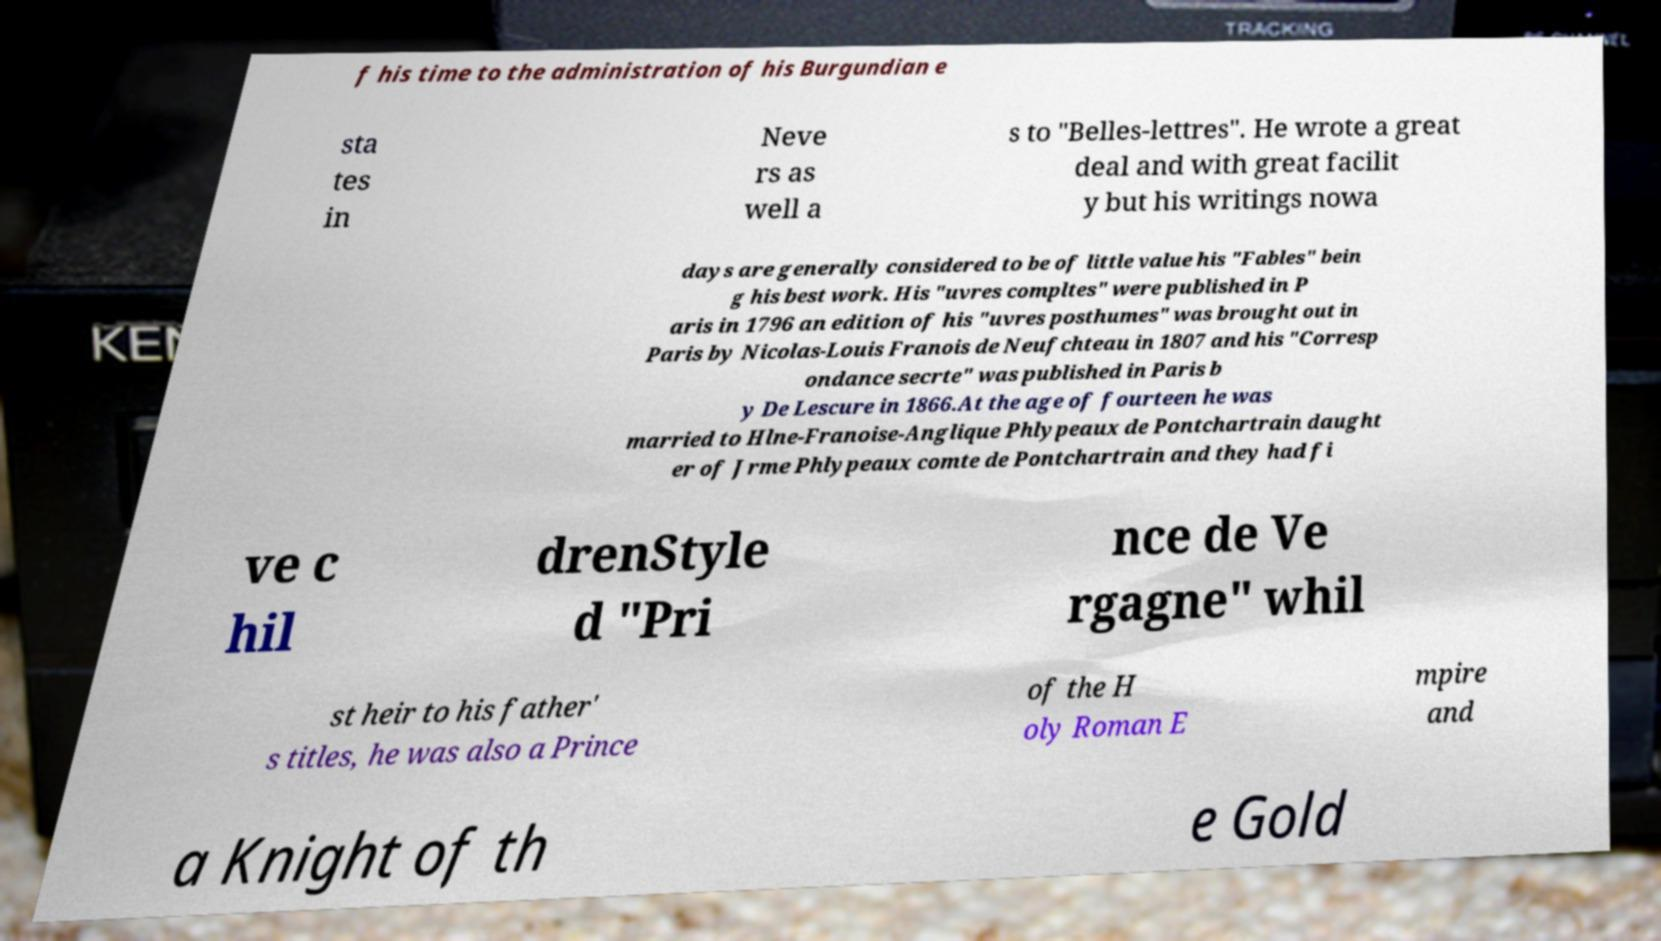Can you accurately transcribe the text from the provided image for me? f his time to the administration of his Burgundian e sta tes in Neve rs as well a s to "Belles-lettres". He wrote a great deal and with great facilit y but his writings nowa days are generally considered to be of little value his "Fables" bein g his best work. His "uvres compltes" were published in P aris in 1796 an edition of his "uvres posthumes" was brought out in Paris by Nicolas-Louis Franois de Neufchteau in 1807 and his "Corresp ondance secrte" was published in Paris b y De Lescure in 1866.At the age of fourteen he was married to Hlne-Franoise-Anglique Phlypeaux de Pontchartrain daught er of Jrme Phlypeaux comte de Pontchartrain and they had fi ve c hil drenStyle d "Pri nce de Ve rgagne" whil st heir to his father' s titles, he was also a Prince of the H oly Roman E mpire and a Knight of th e Gold 